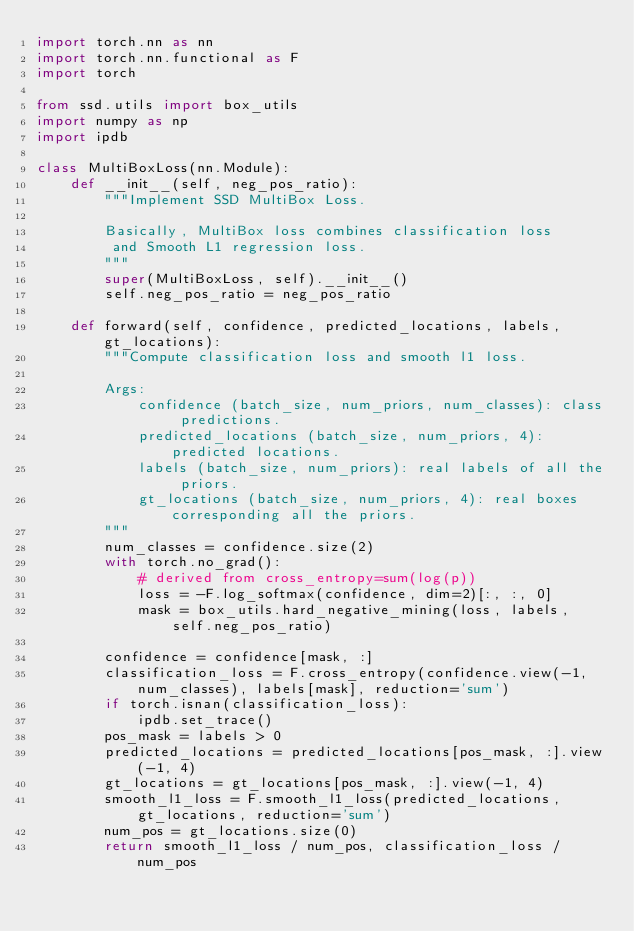Convert code to text. <code><loc_0><loc_0><loc_500><loc_500><_Python_>import torch.nn as nn
import torch.nn.functional as F
import torch

from ssd.utils import box_utils
import numpy as np
import ipdb

class MultiBoxLoss(nn.Module):
    def __init__(self, neg_pos_ratio):
        """Implement SSD MultiBox Loss.

        Basically, MultiBox loss combines classification loss
         and Smooth L1 regression loss.
        """
        super(MultiBoxLoss, self).__init__()
        self.neg_pos_ratio = neg_pos_ratio

    def forward(self, confidence, predicted_locations, labels, gt_locations):
        """Compute classification loss and smooth l1 loss.

        Args:
            confidence (batch_size, num_priors, num_classes): class predictions.
            predicted_locations (batch_size, num_priors, 4): predicted locations.
            labels (batch_size, num_priors): real labels of all the priors.
            gt_locations (batch_size, num_priors, 4): real boxes corresponding all the priors.
        """
        num_classes = confidence.size(2)
        with torch.no_grad():
            # derived from cross_entropy=sum(log(p))
            loss = -F.log_softmax(confidence, dim=2)[:, :, 0]
            mask = box_utils.hard_negative_mining(loss, labels, self.neg_pos_ratio)

        confidence = confidence[mask, :]
        classification_loss = F.cross_entropy(confidence.view(-1, num_classes), labels[mask], reduction='sum')
        if torch.isnan(classification_loss):
            ipdb.set_trace()
        pos_mask = labels > 0
        predicted_locations = predicted_locations[pos_mask, :].view(-1, 4)
        gt_locations = gt_locations[pos_mask, :].view(-1, 4)
        smooth_l1_loss = F.smooth_l1_loss(predicted_locations, gt_locations, reduction='sum')
        num_pos = gt_locations.size(0)
        return smooth_l1_loss / num_pos, classification_loss / num_pos
</code> 